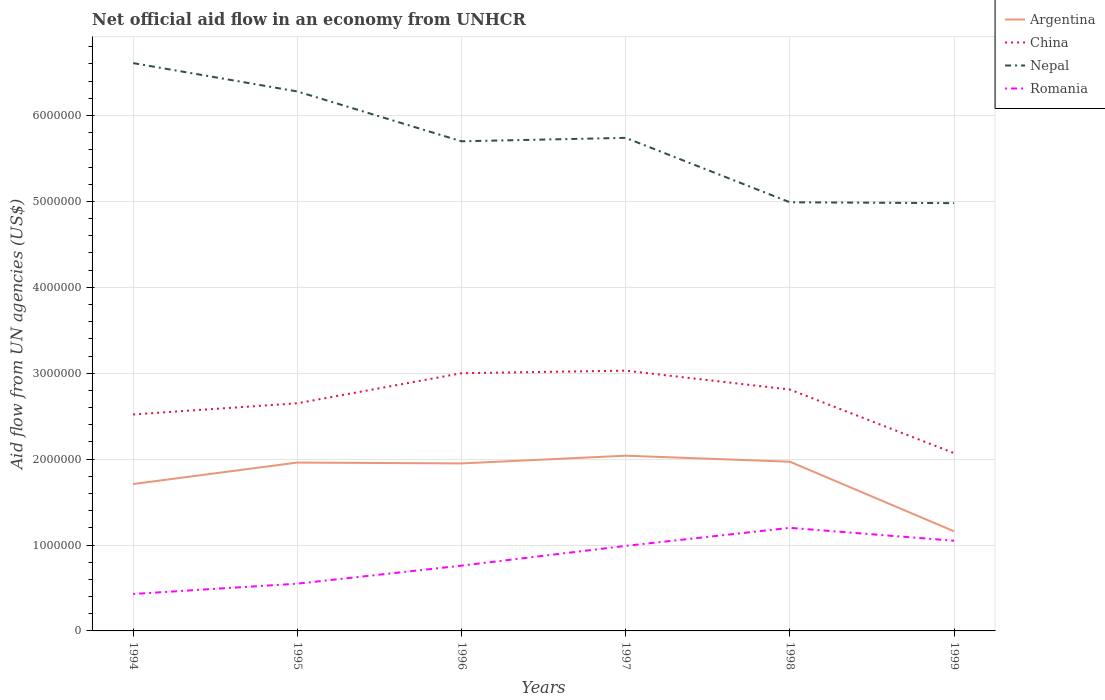Does the line corresponding to Argentina intersect with the line corresponding to Nepal?
Offer a very short reply. No. Across all years, what is the maximum net official aid flow in Nepal?
Ensure brevity in your answer.  4.98e+06. In which year was the net official aid flow in Nepal maximum?
Give a very brief answer. 1999. What is the total net official aid flow in China in the graph?
Make the answer very short. -3.00e+04. What is the difference between the highest and the second highest net official aid flow in Nepal?
Your response must be concise. 1.63e+06. Is the net official aid flow in China strictly greater than the net official aid flow in Argentina over the years?
Provide a short and direct response. No. How many lines are there?
Your answer should be very brief. 4. Are the values on the major ticks of Y-axis written in scientific E-notation?
Provide a succinct answer. No. Does the graph contain any zero values?
Offer a very short reply. No. Where does the legend appear in the graph?
Your answer should be very brief. Top right. How many legend labels are there?
Your answer should be very brief. 4. What is the title of the graph?
Your response must be concise. Net official aid flow in an economy from UNHCR. What is the label or title of the X-axis?
Provide a succinct answer. Years. What is the label or title of the Y-axis?
Provide a succinct answer. Aid flow from UN agencies (US$). What is the Aid flow from UN agencies (US$) in Argentina in 1994?
Provide a short and direct response. 1.71e+06. What is the Aid flow from UN agencies (US$) in China in 1994?
Ensure brevity in your answer.  2.52e+06. What is the Aid flow from UN agencies (US$) of Nepal in 1994?
Offer a very short reply. 6.61e+06. What is the Aid flow from UN agencies (US$) of Romania in 1994?
Make the answer very short. 4.30e+05. What is the Aid flow from UN agencies (US$) of Argentina in 1995?
Provide a short and direct response. 1.96e+06. What is the Aid flow from UN agencies (US$) in China in 1995?
Provide a succinct answer. 2.65e+06. What is the Aid flow from UN agencies (US$) in Nepal in 1995?
Your response must be concise. 6.28e+06. What is the Aid flow from UN agencies (US$) of Romania in 1995?
Make the answer very short. 5.50e+05. What is the Aid flow from UN agencies (US$) of Argentina in 1996?
Ensure brevity in your answer.  1.95e+06. What is the Aid flow from UN agencies (US$) of Nepal in 1996?
Offer a very short reply. 5.70e+06. What is the Aid flow from UN agencies (US$) of Romania in 1996?
Make the answer very short. 7.60e+05. What is the Aid flow from UN agencies (US$) in Argentina in 1997?
Offer a terse response. 2.04e+06. What is the Aid flow from UN agencies (US$) of China in 1997?
Your response must be concise. 3.03e+06. What is the Aid flow from UN agencies (US$) of Nepal in 1997?
Give a very brief answer. 5.74e+06. What is the Aid flow from UN agencies (US$) in Romania in 1997?
Keep it short and to the point. 9.90e+05. What is the Aid flow from UN agencies (US$) of Argentina in 1998?
Your answer should be compact. 1.97e+06. What is the Aid flow from UN agencies (US$) in China in 1998?
Offer a very short reply. 2.81e+06. What is the Aid flow from UN agencies (US$) of Nepal in 1998?
Offer a very short reply. 4.99e+06. What is the Aid flow from UN agencies (US$) of Romania in 1998?
Your response must be concise. 1.20e+06. What is the Aid flow from UN agencies (US$) in Argentina in 1999?
Make the answer very short. 1.16e+06. What is the Aid flow from UN agencies (US$) of China in 1999?
Your answer should be compact. 2.07e+06. What is the Aid flow from UN agencies (US$) in Nepal in 1999?
Keep it short and to the point. 4.98e+06. What is the Aid flow from UN agencies (US$) of Romania in 1999?
Provide a short and direct response. 1.05e+06. Across all years, what is the maximum Aid flow from UN agencies (US$) in Argentina?
Your response must be concise. 2.04e+06. Across all years, what is the maximum Aid flow from UN agencies (US$) in China?
Ensure brevity in your answer.  3.03e+06. Across all years, what is the maximum Aid flow from UN agencies (US$) of Nepal?
Give a very brief answer. 6.61e+06. Across all years, what is the maximum Aid flow from UN agencies (US$) of Romania?
Keep it short and to the point. 1.20e+06. Across all years, what is the minimum Aid flow from UN agencies (US$) of Argentina?
Your answer should be compact. 1.16e+06. Across all years, what is the minimum Aid flow from UN agencies (US$) in China?
Your response must be concise. 2.07e+06. Across all years, what is the minimum Aid flow from UN agencies (US$) in Nepal?
Your response must be concise. 4.98e+06. What is the total Aid flow from UN agencies (US$) in Argentina in the graph?
Your answer should be very brief. 1.08e+07. What is the total Aid flow from UN agencies (US$) of China in the graph?
Provide a short and direct response. 1.61e+07. What is the total Aid flow from UN agencies (US$) of Nepal in the graph?
Your response must be concise. 3.43e+07. What is the total Aid flow from UN agencies (US$) of Romania in the graph?
Your answer should be very brief. 4.98e+06. What is the difference between the Aid flow from UN agencies (US$) of Argentina in 1994 and that in 1995?
Keep it short and to the point. -2.50e+05. What is the difference between the Aid flow from UN agencies (US$) in Romania in 1994 and that in 1995?
Provide a succinct answer. -1.20e+05. What is the difference between the Aid flow from UN agencies (US$) of China in 1994 and that in 1996?
Your answer should be compact. -4.80e+05. What is the difference between the Aid flow from UN agencies (US$) of Nepal in 1994 and that in 1996?
Offer a very short reply. 9.10e+05. What is the difference between the Aid flow from UN agencies (US$) in Romania in 1994 and that in 1996?
Offer a very short reply. -3.30e+05. What is the difference between the Aid flow from UN agencies (US$) in Argentina in 1994 and that in 1997?
Offer a terse response. -3.30e+05. What is the difference between the Aid flow from UN agencies (US$) in China in 1994 and that in 1997?
Provide a succinct answer. -5.10e+05. What is the difference between the Aid flow from UN agencies (US$) of Nepal in 1994 and that in 1997?
Your answer should be very brief. 8.70e+05. What is the difference between the Aid flow from UN agencies (US$) of Romania in 1994 and that in 1997?
Keep it short and to the point. -5.60e+05. What is the difference between the Aid flow from UN agencies (US$) in Argentina in 1994 and that in 1998?
Ensure brevity in your answer.  -2.60e+05. What is the difference between the Aid flow from UN agencies (US$) in China in 1994 and that in 1998?
Make the answer very short. -2.90e+05. What is the difference between the Aid flow from UN agencies (US$) in Nepal in 1994 and that in 1998?
Provide a succinct answer. 1.62e+06. What is the difference between the Aid flow from UN agencies (US$) of Romania in 1994 and that in 1998?
Provide a short and direct response. -7.70e+05. What is the difference between the Aid flow from UN agencies (US$) of China in 1994 and that in 1999?
Keep it short and to the point. 4.50e+05. What is the difference between the Aid flow from UN agencies (US$) in Nepal in 1994 and that in 1999?
Ensure brevity in your answer.  1.63e+06. What is the difference between the Aid flow from UN agencies (US$) in Romania in 1994 and that in 1999?
Your answer should be very brief. -6.20e+05. What is the difference between the Aid flow from UN agencies (US$) in China in 1995 and that in 1996?
Make the answer very short. -3.50e+05. What is the difference between the Aid flow from UN agencies (US$) in Nepal in 1995 and that in 1996?
Offer a terse response. 5.80e+05. What is the difference between the Aid flow from UN agencies (US$) in China in 1995 and that in 1997?
Make the answer very short. -3.80e+05. What is the difference between the Aid flow from UN agencies (US$) in Nepal in 1995 and that in 1997?
Ensure brevity in your answer.  5.40e+05. What is the difference between the Aid flow from UN agencies (US$) of Romania in 1995 and that in 1997?
Offer a terse response. -4.40e+05. What is the difference between the Aid flow from UN agencies (US$) in Argentina in 1995 and that in 1998?
Ensure brevity in your answer.  -10000. What is the difference between the Aid flow from UN agencies (US$) in Nepal in 1995 and that in 1998?
Make the answer very short. 1.29e+06. What is the difference between the Aid flow from UN agencies (US$) in Romania in 1995 and that in 1998?
Your answer should be compact. -6.50e+05. What is the difference between the Aid flow from UN agencies (US$) of China in 1995 and that in 1999?
Keep it short and to the point. 5.80e+05. What is the difference between the Aid flow from UN agencies (US$) in Nepal in 1995 and that in 1999?
Provide a short and direct response. 1.30e+06. What is the difference between the Aid flow from UN agencies (US$) of Romania in 1995 and that in 1999?
Your answer should be very brief. -5.00e+05. What is the difference between the Aid flow from UN agencies (US$) of Argentina in 1996 and that in 1997?
Your response must be concise. -9.00e+04. What is the difference between the Aid flow from UN agencies (US$) of Argentina in 1996 and that in 1998?
Your answer should be very brief. -2.00e+04. What is the difference between the Aid flow from UN agencies (US$) in Nepal in 1996 and that in 1998?
Offer a terse response. 7.10e+05. What is the difference between the Aid flow from UN agencies (US$) of Romania in 1996 and that in 1998?
Ensure brevity in your answer.  -4.40e+05. What is the difference between the Aid flow from UN agencies (US$) in Argentina in 1996 and that in 1999?
Provide a succinct answer. 7.90e+05. What is the difference between the Aid flow from UN agencies (US$) in China in 1996 and that in 1999?
Your answer should be compact. 9.30e+05. What is the difference between the Aid flow from UN agencies (US$) of Nepal in 1996 and that in 1999?
Your answer should be very brief. 7.20e+05. What is the difference between the Aid flow from UN agencies (US$) of Argentina in 1997 and that in 1998?
Offer a terse response. 7.00e+04. What is the difference between the Aid flow from UN agencies (US$) in Nepal in 1997 and that in 1998?
Your response must be concise. 7.50e+05. What is the difference between the Aid flow from UN agencies (US$) of Romania in 1997 and that in 1998?
Provide a short and direct response. -2.10e+05. What is the difference between the Aid flow from UN agencies (US$) of Argentina in 1997 and that in 1999?
Make the answer very short. 8.80e+05. What is the difference between the Aid flow from UN agencies (US$) of China in 1997 and that in 1999?
Ensure brevity in your answer.  9.60e+05. What is the difference between the Aid flow from UN agencies (US$) in Nepal in 1997 and that in 1999?
Your answer should be very brief. 7.60e+05. What is the difference between the Aid flow from UN agencies (US$) of Romania in 1997 and that in 1999?
Your response must be concise. -6.00e+04. What is the difference between the Aid flow from UN agencies (US$) in Argentina in 1998 and that in 1999?
Keep it short and to the point. 8.10e+05. What is the difference between the Aid flow from UN agencies (US$) of China in 1998 and that in 1999?
Your answer should be very brief. 7.40e+05. What is the difference between the Aid flow from UN agencies (US$) of Argentina in 1994 and the Aid flow from UN agencies (US$) of China in 1995?
Offer a very short reply. -9.40e+05. What is the difference between the Aid flow from UN agencies (US$) of Argentina in 1994 and the Aid flow from UN agencies (US$) of Nepal in 1995?
Make the answer very short. -4.57e+06. What is the difference between the Aid flow from UN agencies (US$) of Argentina in 1994 and the Aid flow from UN agencies (US$) of Romania in 1995?
Your response must be concise. 1.16e+06. What is the difference between the Aid flow from UN agencies (US$) in China in 1994 and the Aid flow from UN agencies (US$) in Nepal in 1995?
Your answer should be compact. -3.76e+06. What is the difference between the Aid flow from UN agencies (US$) in China in 1994 and the Aid flow from UN agencies (US$) in Romania in 1995?
Your answer should be very brief. 1.97e+06. What is the difference between the Aid flow from UN agencies (US$) in Nepal in 1994 and the Aid flow from UN agencies (US$) in Romania in 1995?
Ensure brevity in your answer.  6.06e+06. What is the difference between the Aid flow from UN agencies (US$) of Argentina in 1994 and the Aid flow from UN agencies (US$) of China in 1996?
Keep it short and to the point. -1.29e+06. What is the difference between the Aid flow from UN agencies (US$) of Argentina in 1994 and the Aid flow from UN agencies (US$) of Nepal in 1996?
Make the answer very short. -3.99e+06. What is the difference between the Aid flow from UN agencies (US$) of Argentina in 1994 and the Aid flow from UN agencies (US$) of Romania in 1996?
Give a very brief answer. 9.50e+05. What is the difference between the Aid flow from UN agencies (US$) of China in 1994 and the Aid flow from UN agencies (US$) of Nepal in 1996?
Make the answer very short. -3.18e+06. What is the difference between the Aid flow from UN agencies (US$) in China in 1994 and the Aid flow from UN agencies (US$) in Romania in 1996?
Give a very brief answer. 1.76e+06. What is the difference between the Aid flow from UN agencies (US$) in Nepal in 1994 and the Aid flow from UN agencies (US$) in Romania in 1996?
Your answer should be very brief. 5.85e+06. What is the difference between the Aid flow from UN agencies (US$) in Argentina in 1994 and the Aid flow from UN agencies (US$) in China in 1997?
Your answer should be compact. -1.32e+06. What is the difference between the Aid flow from UN agencies (US$) in Argentina in 1994 and the Aid flow from UN agencies (US$) in Nepal in 1997?
Your answer should be compact. -4.03e+06. What is the difference between the Aid flow from UN agencies (US$) of Argentina in 1994 and the Aid flow from UN agencies (US$) of Romania in 1997?
Your answer should be compact. 7.20e+05. What is the difference between the Aid flow from UN agencies (US$) in China in 1994 and the Aid flow from UN agencies (US$) in Nepal in 1997?
Provide a succinct answer. -3.22e+06. What is the difference between the Aid flow from UN agencies (US$) of China in 1994 and the Aid flow from UN agencies (US$) of Romania in 1997?
Your answer should be very brief. 1.53e+06. What is the difference between the Aid flow from UN agencies (US$) of Nepal in 1994 and the Aid flow from UN agencies (US$) of Romania in 1997?
Your response must be concise. 5.62e+06. What is the difference between the Aid flow from UN agencies (US$) of Argentina in 1994 and the Aid flow from UN agencies (US$) of China in 1998?
Offer a terse response. -1.10e+06. What is the difference between the Aid flow from UN agencies (US$) in Argentina in 1994 and the Aid flow from UN agencies (US$) in Nepal in 1998?
Give a very brief answer. -3.28e+06. What is the difference between the Aid flow from UN agencies (US$) in Argentina in 1994 and the Aid flow from UN agencies (US$) in Romania in 1998?
Your response must be concise. 5.10e+05. What is the difference between the Aid flow from UN agencies (US$) of China in 1994 and the Aid flow from UN agencies (US$) of Nepal in 1998?
Keep it short and to the point. -2.47e+06. What is the difference between the Aid flow from UN agencies (US$) in China in 1994 and the Aid flow from UN agencies (US$) in Romania in 1998?
Ensure brevity in your answer.  1.32e+06. What is the difference between the Aid flow from UN agencies (US$) of Nepal in 1994 and the Aid flow from UN agencies (US$) of Romania in 1998?
Provide a succinct answer. 5.41e+06. What is the difference between the Aid flow from UN agencies (US$) of Argentina in 1994 and the Aid flow from UN agencies (US$) of China in 1999?
Your response must be concise. -3.60e+05. What is the difference between the Aid flow from UN agencies (US$) of Argentina in 1994 and the Aid flow from UN agencies (US$) of Nepal in 1999?
Keep it short and to the point. -3.27e+06. What is the difference between the Aid flow from UN agencies (US$) of China in 1994 and the Aid flow from UN agencies (US$) of Nepal in 1999?
Offer a very short reply. -2.46e+06. What is the difference between the Aid flow from UN agencies (US$) of China in 1994 and the Aid flow from UN agencies (US$) of Romania in 1999?
Ensure brevity in your answer.  1.47e+06. What is the difference between the Aid flow from UN agencies (US$) of Nepal in 1994 and the Aid flow from UN agencies (US$) of Romania in 1999?
Offer a very short reply. 5.56e+06. What is the difference between the Aid flow from UN agencies (US$) of Argentina in 1995 and the Aid flow from UN agencies (US$) of China in 1996?
Provide a succinct answer. -1.04e+06. What is the difference between the Aid flow from UN agencies (US$) of Argentina in 1995 and the Aid flow from UN agencies (US$) of Nepal in 1996?
Provide a succinct answer. -3.74e+06. What is the difference between the Aid flow from UN agencies (US$) in Argentina in 1995 and the Aid flow from UN agencies (US$) in Romania in 1996?
Give a very brief answer. 1.20e+06. What is the difference between the Aid flow from UN agencies (US$) in China in 1995 and the Aid flow from UN agencies (US$) in Nepal in 1996?
Your response must be concise. -3.05e+06. What is the difference between the Aid flow from UN agencies (US$) of China in 1995 and the Aid flow from UN agencies (US$) of Romania in 1996?
Provide a short and direct response. 1.89e+06. What is the difference between the Aid flow from UN agencies (US$) in Nepal in 1995 and the Aid flow from UN agencies (US$) in Romania in 1996?
Your answer should be compact. 5.52e+06. What is the difference between the Aid flow from UN agencies (US$) in Argentina in 1995 and the Aid flow from UN agencies (US$) in China in 1997?
Your answer should be compact. -1.07e+06. What is the difference between the Aid flow from UN agencies (US$) of Argentina in 1995 and the Aid flow from UN agencies (US$) of Nepal in 1997?
Keep it short and to the point. -3.78e+06. What is the difference between the Aid flow from UN agencies (US$) in Argentina in 1995 and the Aid flow from UN agencies (US$) in Romania in 1997?
Provide a succinct answer. 9.70e+05. What is the difference between the Aid flow from UN agencies (US$) in China in 1995 and the Aid flow from UN agencies (US$) in Nepal in 1997?
Offer a very short reply. -3.09e+06. What is the difference between the Aid flow from UN agencies (US$) of China in 1995 and the Aid flow from UN agencies (US$) of Romania in 1997?
Your answer should be compact. 1.66e+06. What is the difference between the Aid flow from UN agencies (US$) in Nepal in 1995 and the Aid flow from UN agencies (US$) in Romania in 1997?
Ensure brevity in your answer.  5.29e+06. What is the difference between the Aid flow from UN agencies (US$) in Argentina in 1995 and the Aid flow from UN agencies (US$) in China in 1998?
Your response must be concise. -8.50e+05. What is the difference between the Aid flow from UN agencies (US$) in Argentina in 1995 and the Aid flow from UN agencies (US$) in Nepal in 1998?
Keep it short and to the point. -3.03e+06. What is the difference between the Aid flow from UN agencies (US$) of Argentina in 1995 and the Aid flow from UN agencies (US$) of Romania in 1998?
Provide a short and direct response. 7.60e+05. What is the difference between the Aid flow from UN agencies (US$) in China in 1995 and the Aid flow from UN agencies (US$) in Nepal in 1998?
Your answer should be very brief. -2.34e+06. What is the difference between the Aid flow from UN agencies (US$) of China in 1995 and the Aid flow from UN agencies (US$) of Romania in 1998?
Provide a succinct answer. 1.45e+06. What is the difference between the Aid flow from UN agencies (US$) of Nepal in 1995 and the Aid flow from UN agencies (US$) of Romania in 1998?
Offer a very short reply. 5.08e+06. What is the difference between the Aid flow from UN agencies (US$) in Argentina in 1995 and the Aid flow from UN agencies (US$) in China in 1999?
Give a very brief answer. -1.10e+05. What is the difference between the Aid flow from UN agencies (US$) of Argentina in 1995 and the Aid flow from UN agencies (US$) of Nepal in 1999?
Your answer should be compact. -3.02e+06. What is the difference between the Aid flow from UN agencies (US$) of Argentina in 1995 and the Aid flow from UN agencies (US$) of Romania in 1999?
Provide a short and direct response. 9.10e+05. What is the difference between the Aid flow from UN agencies (US$) of China in 1995 and the Aid flow from UN agencies (US$) of Nepal in 1999?
Provide a succinct answer. -2.33e+06. What is the difference between the Aid flow from UN agencies (US$) in China in 1995 and the Aid flow from UN agencies (US$) in Romania in 1999?
Offer a terse response. 1.60e+06. What is the difference between the Aid flow from UN agencies (US$) in Nepal in 1995 and the Aid flow from UN agencies (US$) in Romania in 1999?
Your answer should be compact. 5.23e+06. What is the difference between the Aid flow from UN agencies (US$) of Argentina in 1996 and the Aid flow from UN agencies (US$) of China in 1997?
Provide a short and direct response. -1.08e+06. What is the difference between the Aid flow from UN agencies (US$) in Argentina in 1996 and the Aid flow from UN agencies (US$) in Nepal in 1997?
Your answer should be very brief. -3.79e+06. What is the difference between the Aid flow from UN agencies (US$) in Argentina in 1996 and the Aid flow from UN agencies (US$) in Romania in 1997?
Provide a succinct answer. 9.60e+05. What is the difference between the Aid flow from UN agencies (US$) in China in 1996 and the Aid flow from UN agencies (US$) in Nepal in 1997?
Provide a short and direct response. -2.74e+06. What is the difference between the Aid flow from UN agencies (US$) of China in 1996 and the Aid flow from UN agencies (US$) of Romania in 1997?
Offer a very short reply. 2.01e+06. What is the difference between the Aid flow from UN agencies (US$) in Nepal in 1996 and the Aid flow from UN agencies (US$) in Romania in 1997?
Keep it short and to the point. 4.71e+06. What is the difference between the Aid flow from UN agencies (US$) in Argentina in 1996 and the Aid flow from UN agencies (US$) in China in 1998?
Offer a terse response. -8.60e+05. What is the difference between the Aid flow from UN agencies (US$) of Argentina in 1996 and the Aid flow from UN agencies (US$) of Nepal in 1998?
Ensure brevity in your answer.  -3.04e+06. What is the difference between the Aid flow from UN agencies (US$) of Argentina in 1996 and the Aid flow from UN agencies (US$) of Romania in 1998?
Your answer should be compact. 7.50e+05. What is the difference between the Aid flow from UN agencies (US$) in China in 1996 and the Aid flow from UN agencies (US$) in Nepal in 1998?
Ensure brevity in your answer.  -1.99e+06. What is the difference between the Aid flow from UN agencies (US$) of China in 1996 and the Aid flow from UN agencies (US$) of Romania in 1998?
Offer a terse response. 1.80e+06. What is the difference between the Aid flow from UN agencies (US$) in Nepal in 1996 and the Aid flow from UN agencies (US$) in Romania in 1998?
Make the answer very short. 4.50e+06. What is the difference between the Aid flow from UN agencies (US$) of Argentina in 1996 and the Aid flow from UN agencies (US$) of Nepal in 1999?
Offer a very short reply. -3.03e+06. What is the difference between the Aid flow from UN agencies (US$) in China in 1996 and the Aid flow from UN agencies (US$) in Nepal in 1999?
Ensure brevity in your answer.  -1.98e+06. What is the difference between the Aid flow from UN agencies (US$) of China in 1996 and the Aid flow from UN agencies (US$) of Romania in 1999?
Provide a short and direct response. 1.95e+06. What is the difference between the Aid flow from UN agencies (US$) in Nepal in 1996 and the Aid flow from UN agencies (US$) in Romania in 1999?
Your response must be concise. 4.65e+06. What is the difference between the Aid flow from UN agencies (US$) in Argentina in 1997 and the Aid flow from UN agencies (US$) in China in 1998?
Keep it short and to the point. -7.70e+05. What is the difference between the Aid flow from UN agencies (US$) in Argentina in 1997 and the Aid flow from UN agencies (US$) in Nepal in 1998?
Provide a short and direct response. -2.95e+06. What is the difference between the Aid flow from UN agencies (US$) of Argentina in 1997 and the Aid flow from UN agencies (US$) of Romania in 1998?
Offer a terse response. 8.40e+05. What is the difference between the Aid flow from UN agencies (US$) of China in 1997 and the Aid flow from UN agencies (US$) of Nepal in 1998?
Your response must be concise. -1.96e+06. What is the difference between the Aid flow from UN agencies (US$) in China in 1997 and the Aid flow from UN agencies (US$) in Romania in 1998?
Offer a very short reply. 1.83e+06. What is the difference between the Aid flow from UN agencies (US$) in Nepal in 1997 and the Aid flow from UN agencies (US$) in Romania in 1998?
Make the answer very short. 4.54e+06. What is the difference between the Aid flow from UN agencies (US$) in Argentina in 1997 and the Aid flow from UN agencies (US$) in Nepal in 1999?
Give a very brief answer. -2.94e+06. What is the difference between the Aid flow from UN agencies (US$) of Argentina in 1997 and the Aid flow from UN agencies (US$) of Romania in 1999?
Make the answer very short. 9.90e+05. What is the difference between the Aid flow from UN agencies (US$) in China in 1997 and the Aid flow from UN agencies (US$) in Nepal in 1999?
Offer a very short reply. -1.95e+06. What is the difference between the Aid flow from UN agencies (US$) of China in 1997 and the Aid flow from UN agencies (US$) of Romania in 1999?
Make the answer very short. 1.98e+06. What is the difference between the Aid flow from UN agencies (US$) of Nepal in 1997 and the Aid flow from UN agencies (US$) of Romania in 1999?
Give a very brief answer. 4.69e+06. What is the difference between the Aid flow from UN agencies (US$) of Argentina in 1998 and the Aid flow from UN agencies (US$) of China in 1999?
Give a very brief answer. -1.00e+05. What is the difference between the Aid flow from UN agencies (US$) of Argentina in 1998 and the Aid flow from UN agencies (US$) of Nepal in 1999?
Offer a very short reply. -3.01e+06. What is the difference between the Aid flow from UN agencies (US$) of Argentina in 1998 and the Aid flow from UN agencies (US$) of Romania in 1999?
Your answer should be compact. 9.20e+05. What is the difference between the Aid flow from UN agencies (US$) in China in 1998 and the Aid flow from UN agencies (US$) in Nepal in 1999?
Give a very brief answer. -2.17e+06. What is the difference between the Aid flow from UN agencies (US$) in China in 1998 and the Aid flow from UN agencies (US$) in Romania in 1999?
Give a very brief answer. 1.76e+06. What is the difference between the Aid flow from UN agencies (US$) of Nepal in 1998 and the Aid flow from UN agencies (US$) of Romania in 1999?
Keep it short and to the point. 3.94e+06. What is the average Aid flow from UN agencies (US$) in Argentina per year?
Your answer should be very brief. 1.80e+06. What is the average Aid flow from UN agencies (US$) of China per year?
Offer a terse response. 2.68e+06. What is the average Aid flow from UN agencies (US$) of Nepal per year?
Give a very brief answer. 5.72e+06. What is the average Aid flow from UN agencies (US$) of Romania per year?
Offer a terse response. 8.30e+05. In the year 1994, what is the difference between the Aid flow from UN agencies (US$) of Argentina and Aid flow from UN agencies (US$) of China?
Keep it short and to the point. -8.10e+05. In the year 1994, what is the difference between the Aid flow from UN agencies (US$) in Argentina and Aid flow from UN agencies (US$) in Nepal?
Give a very brief answer. -4.90e+06. In the year 1994, what is the difference between the Aid flow from UN agencies (US$) in Argentina and Aid flow from UN agencies (US$) in Romania?
Give a very brief answer. 1.28e+06. In the year 1994, what is the difference between the Aid flow from UN agencies (US$) in China and Aid flow from UN agencies (US$) in Nepal?
Make the answer very short. -4.09e+06. In the year 1994, what is the difference between the Aid flow from UN agencies (US$) of China and Aid flow from UN agencies (US$) of Romania?
Your answer should be very brief. 2.09e+06. In the year 1994, what is the difference between the Aid flow from UN agencies (US$) in Nepal and Aid flow from UN agencies (US$) in Romania?
Provide a short and direct response. 6.18e+06. In the year 1995, what is the difference between the Aid flow from UN agencies (US$) of Argentina and Aid flow from UN agencies (US$) of China?
Provide a succinct answer. -6.90e+05. In the year 1995, what is the difference between the Aid flow from UN agencies (US$) of Argentina and Aid flow from UN agencies (US$) of Nepal?
Provide a succinct answer. -4.32e+06. In the year 1995, what is the difference between the Aid flow from UN agencies (US$) in Argentina and Aid flow from UN agencies (US$) in Romania?
Keep it short and to the point. 1.41e+06. In the year 1995, what is the difference between the Aid flow from UN agencies (US$) in China and Aid flow from UN agencies (US$) in Nepal?
Make the answer very short. -3.63e+06. In the year 1995, what is the difference between the Aid flow from UN agencies (US$) in China and Aid flow from UN agencies (US$) in Romania?
Your answer should be very brief. 2.10e+06. In the year 1995, what is the difference between the Aid flow from UN agencies (US$) in Nepal and Aid flow from UN agencies (US$) in Romania?
Offer a very short reply. 5.73e+06. In the year 1996, what is the difference between the Aid flow from UN agencies (US$) of Argentina and Aid flow from UN agencies (US$) of China?
Offer a very short reply. -1.05e+06. In the year 1996, what is the difference between the Aid flow from UN agencies (US$) of Argentina and Aid flow from UN agencies (US$) of Nepal?
Give a very brief answer. -3.75e+06. In the year 1996, what is the difference between the Aid flow from UN agencies (US$) in Argentina and Aid flow from UN agencies (US$) in Romania?
Offer a terse response. 1.19e+06. In the year 1996, what is the difference between the Aid flow from UN agencies (US$) in China and Aid flow from UN agencies (US$) in Nepal?
Provide a succinct answer. -2.70e+06. In the year 1996, what is the difference between the Aid flow from UN agencies (US$) in China and Aid flow from UN agencies (US$) in Romania?
Provide a short and direct response. 2.24e+06. In the year 1996, what is the difference between the Aid flow from UN agencies (US$) in Nepal and Aid flow from UN agencies (US$) in Romania?
Give a very brief answer. 4.94e+06. In the year 1997, what is the difference between the Aid flow from UN agencies (US$) of Argentina and Aid flow from UN agencies (US$) of China?
Your answer should be very brief. -9.90e+05. In the year 1997, what is the difference between the Aid flow from UN agencies (US$) of Argentina and Aid flow from UN agencies (US$) of Nepal?
Your response must be concise. -3.70e+06. In the year 1997, what is the difference between the Aid flow from UN agencies (US$) of Argentina and Aid flow from UN agencies (US$) of Romania?
Keep it short and to the point. 1.05e+06. In the year 1997, what is the difference between the Aid flow from UN agencies (US$) in China and Aid flow from UN agencies (US$) in Nepal?
Offer a very short reply. -2.71e+06. In the year 1997, what is the difference between the Aid flow from UN agencies (US$) of China and Aid flow from UN agencies (US$) of Romania?
Provide a short and direct response. 2.04e+06. In the year 1997, what is the difference between the Aid flow from UN agencies (US$) of Nepal and Aid flow from UN agencies (US$) of Romania?
Provide a short and direct response. 4.75e+06. In the year 1998, what is the difference between the Aid flow from UN agencies (US$) in Argentina and Aid flow from UN agencies (US$) in China?
Offer a terse response. -8.40e+05. In the year 1998, what is the difference between the Aid flow from UN agencies (US$) of Argentina and Aid flow from UN agencies (US$) of Nepal?
Your answer should be very brief. -3.02e+06. In the year 1998, what is the difference between the Aid flow from UN agencies (US$) of Argentina and Aid flow from UN agencies (US$) of Romania?
Offer a terse response. 7.70e+05. In the year 1998, what is the difference between the Aid flow from UN agencies (US$) in China and Aid flow from UN agencies (US$) in Nepal?
Your answer should be very brief. -2.18e+06. In the year 1998, what is the difference between the Aid flow from UN agencies (US$) in China and Aid flow from UN agencies (US$) in Romania?
Keep it short and to the point. 1.61e+06. In the year 1998, what is the difference between the Aid flow from UN agencies (US$) in Nepal and Aid flow from UN agencies (US$) in Romania?
Your answer should be very brief. 3.79e+06. In the year 1999, what is the difference between the Aid flow from UN agencies (US$) of Argentina and Aid flow from UN agencies (US$) of China?
Offer a very short reply. -9.10e+05. In the year 1999, what is the difference between the Aid flow from UN agencies (US$) of Argentina and Aid flow from UN agencies (US$) of Nepal?
Ensure brevity in your answer.  -3.82e+06. In the year 1999, what is the difference between the Aid flow from UN agencies (US$) in Argentina and Aid flow from UN agencies (US$) in Romania?
Make the answer very short. 1.10e+05. In the year 1999, what is the difference between the Aid flow from UN agencies (US$) in China and Aid flow from UN agencies (US$) in Nepal?
Provide a short and direct response. -2.91e+06. In the year 1999, what is the difference between the Aid flow from UN agencies (US$) in China and Aid flow from UN agencies (US$) in Romania?
Give a very brief answer. 1.02e+06. In the year 1999, what is the difference between the Aid flow from UN agencies (US$) in Nepal and Aid flow from UN agencies (US$) in Romania?
Offer a terse response. 3.93e+06. What is the ratio of the Aid flow from UN agencies (US$) in Argentina in 1994 to that in 1995?
Provide a succinct answer. 0.87. What is the ratio of the Aid flow from UN agencies (US$) of China in 1994 to that in 1995?
Your answer should be compact. 0.95. What is the ratio of the Aid flow from UN agencies (US$) of Nepal in 1994 to that in 1995?
Ensure brevity in your answer.  1.05. What is the ratio of the Aid flow from UN agencies (US$) in Romania in 1994 to that in 1995?
Keep it short and to the point. 0.78. What is the ratio of the Aid flow from UN agencies (US$) of Argentina in 1994 to that in 1996?
Keep it short and to the point. 0.88. What is the ratio of the Aid flow from UN agencies (US$) in China in 1994 to that in 1996?
Your answer should be very brief. 0.84. What is the ratio of the Aid flow from UN agencies (US$) in Nepal in 1994 to that in 1996?
Give a very brief answer. 1.16. What is the ratio of the Aid flow from UN agencies (US$) of Romania in 1994 to that in 1996?
Make the answer very short. 0.57. What is the ratio of the Aid flow from UN agencies (US$) of Argentina in 1994 to that in 1997?
Make the answer very short. 0.84. What is the ratio of the Aid flow from UN agencies (US$) of China in 1994 to that in 1997?
Your answer should be very brief. 0.83. What is the ratio of the Aid flow from UN agencies (US$) of Nepal in 1994 to that in 1997?
Offer a terse response. 1.15. What is the ratio of the Aid flow from UN agencies (US$) of Romania in 1994 to that in 1997?
Offer a very short reply. 0.43. What is the ratio of the Aid flow from UN agencies (US$) in Argentina in 1994 to that in 1998?
Your answer should be compact. 0.87. What is the ratio of the Aid flow from UN agencies (US$) of China in 1994 to that in 1998?
Your answer should be compact. 0.9. What is the ratio of the Aid flow from UN agencies (US$) in Nepal in 1994 to that in 1998?
Offer a very short reply. 1.32. What is the ratio of the Aid flow from UN agencies (US$) of Romania in 1994 to that in 1998?
Make the answer very short. 0.36. What is the ratio of the Aid flow from UN agencies (US$) in Argentina in 1994 to that in 1999?
Your answer should be compact. 1.47. What is the ratio of the Aid flow from UN agencies (US$) in China in 1994 to that in 1999?
Your answer should be compact. 1.22. What is the ratio of the Aid flow from UN agencies (US$) of Nepal in 1994 to that in 1999?
Provide a succinct answer. 1.33. What is the ratio of the Aid flow from UN agencies (US$) in Romania in 1994 to that in 1999?
Provide a succinct answer. 0.41. What is the ratio of the Aid flow from UN agencies (US$) of China in 1995 to that in 1996?
Keep it short and to the point. 0.88. What is the ratio of the Aid flow from UN agencies (US$) in Nepal in 1995 to that in 1996?
Give a very brief answer. 1.1. What is the ratio of the Aid flow from UN agencies (US$) in Romania in 1995 to that in 1996?
Your answer should be compact. 0.72. What is the ratio of the Aid flow from UN agencies (US$) in Argentina in 1995 to that in 1997?
Offer a terse response. 0.96. What is the ratio of the Aid flow from UN agencies (US$) of China in 1995 to that in 1997?
Make the answer very short. 0.87. What is the ratio of the Aid flow from UN agencies (US$) in Nepal in 1995 to that in 1997?
Your answer should be very brief. 1.09. What is the ratio of the Aid flow from UN agencies (US$) in Romania in 1995 to that in 1997?
Provide a short and direct response. 0.56. What is the ratio of the Aid flow from UN agencies (US$) in China in 1995 to that in 1998?
Provide a short and direct response. 0.94. What is the ratio of the Aid flow from UN agencies (US$) in Nepal in 1995 to that in 1998?
Offer a very short reply. 1.26. What is the ratio of the Aid flow from UN agencies (US$) in Romania in 1995 to that in 1998?
Your response must be concise. 0.46. What is the ratio of the Aid flow from UN agencies (US$) of Argentina in 1995 to that in 1999?
Your answer should be very brief. 1.69. What is the ratio of the Aid flow from UN agencies (US$) in China in 1995 to that in 1999?
Your response must be concise. 1.28. What is the ratio of the Aid flow from UN agencies (US$) in Nepal in 1995 to that in 1999?
Your answer should be compact. 1.26. What is the ratio of the Aid flow from UN agencies (US$) of Romania in 1995 to that in 1999?
Provide a succinct answer. 0.52. What is the ratio of the Aid flow from UN agencies (US$) of Argentina in 1996 to that in 1997?
Provide a succinct answer. 0.96. What is the ratio of the Aid flow from UN agencies (US$) in China in 1996 to that in 1997?
Provide a succinct answer. 0.99. What is the ratio of the Aid flow from UN agencies (US$) of Nepal in 1996 to that in 1997?
Your answer should be very brief. 0.99. What is the ratio of the Aid flow from UN agencies (US$) of Romania in 1996 to that in 1997?
Ensure brevity in your answer.  0.77. What is the ratio of the Aid flow from UN agencies (US$) of Argentina in 1996 to that in 1998?
Give a very brief answer. 0.99. What is the ratio of the Aid flow from UN agencies (US$) of China in 1996 to that in 1998?
Provide a succinct answer. 1.07. What is the ratio of the Aid flow from UN agencies (US$) in Nepal in 1996 to that in 1998?
Provide a short and direct response. 1.14. What is the ratio of the Aid flow from UN agencies (US$) of Romania in 1996 to that in 1998?
Give a very brief answer. 0.63. What is the ratio of the Aid flow from UN agencies (US$) of Argentina in 1996 to that in 1999?
Your response must be concise. 1.68. What is the ratio of the Aid flow from UN agencies (US$) of China in 1996 to that in 1999?
Provide a succinct answer. 1.45. What is the ratio of the Aid flow from UN agencies (US$) of Nepal in 1996 to that in 1999?
Provide a short and direct response. 1.14. What is the ratio of the Aid flow from UN agencies (US$) in Romania in 1996 to that in 1999?
Offer a very short reply. 0.72. What is the ratio of the Aid flow from UN agencies (US$) in Argentina in 1997 to that in 1998?
Offer a terse response. 1.04. What is the ratio of the Aid flow from UN agencies (US$) in China in 1997 to that in 1998?
Provide a succinct answer. 1.08. What is the ratio of the Aid flow from UN agencies (US$) of Nepal in 1997 to that in 1998?
Provide a succinct answer. 1.15. What is the ratio of the Aid flow from UN agencies (US$) of Romania in 1997 to that in 1998?
Provide a succinct answer. 0.82. What is the ratio of the Aid flow from UN agencies (US$) of Argentina in 1997 to that in 1999?
Ensure brevity in your answer.  1.76. What is the ratio of the Aid flow from UN agencies (US$) in China in 1997 to that in 1999?
Provide a succinct answer. 1.46. What is the ratio of the Aid flow from UN agencies (US$) in Nepal in 1997 to that in 1999?
Offer a very short reply. 1.15. What is the ratio of the Aid flow from UN agencies (US$) of Romania in 1997 to that in 1999?
Your answer should be compact. 0.94. What is the ratio of the Aid flow from UN agencies (US$) of Argentina in 1998 to that in 1999?
Ensure brevity in your answer.  1.7. What is the ratio of the Aid flow from UN agencies (US$) in China in 1998 to that in 1999?
Make the answer very short. 1.36. What is the ratio of the Aid flow from UN agencies (US$) in Romania in 1998 to that in 1999?
Your answer should be very brief. 1.14. What is the difference between the highest and the second highest Aid flow from UN agencies (US$) in Argentina?
Keep it short and to the point. 7.00e+04. What is the difference between the highest and the lowest Aid flow from UN agencies (US$) of Argentina?
Offer a terse response. 8.80e+05. What is the difference between the highest and the lowest Aid flow from UN agencies (US$) in China?
Give a very brief answer. 9.60e+05. What is the difference between the highest and the lowest Aid flow from UN agencies (US$) in Nepal?
Keep it short and to the point. 1.63e+06. What is the difference between the highest and the lowest Aid flow from UN agencies (US$) in Romania?
Provide a short and direct response. 7.70e+05. 